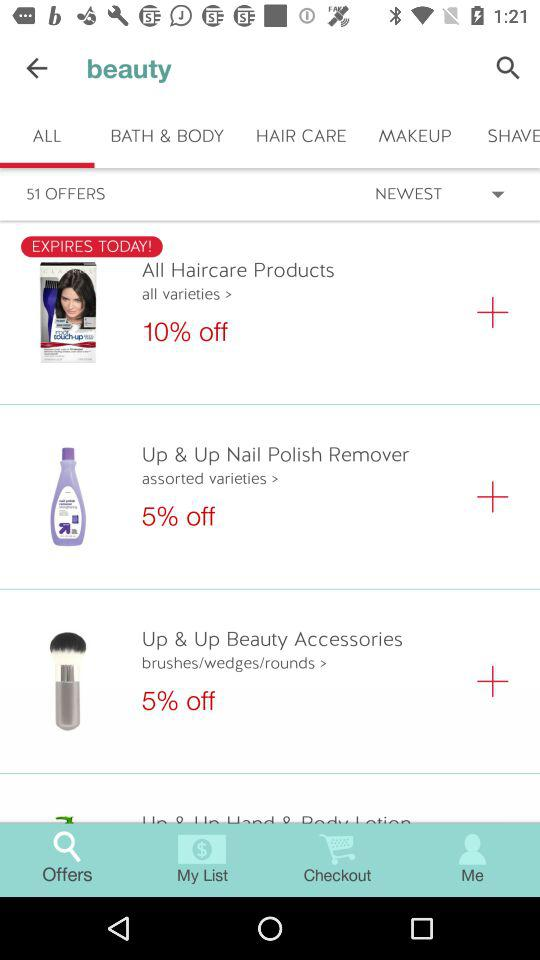Which category of beauty am I in? The category is "ALL". 